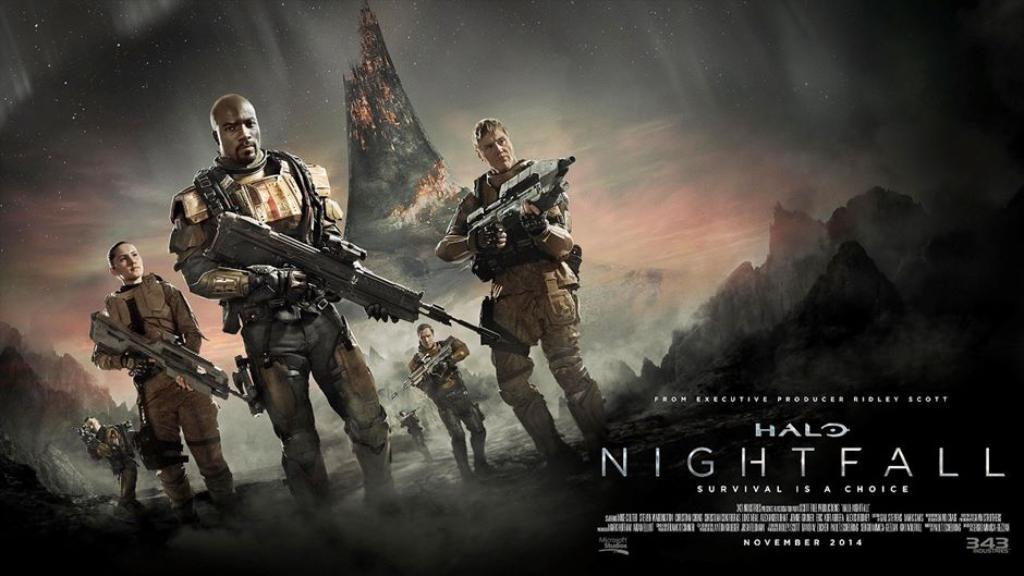What is featured in the image? There is a poster in the image. What can be seen on the poster? The poster contains images of people. How are the people depicted on the poster? The people in the poster are standing. What are the people holding in the poster? The people in the poster are holding weapons. What type of vegetable is being gripped by the tail of the person in the image? There is no vegetable or tail present in the image; it features a poster with images of people holding weapons. 